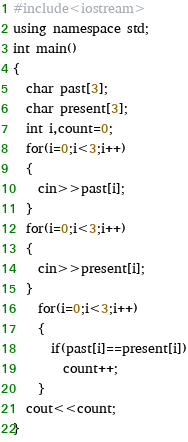Convert code to text. <code><loc_0><loc_0><loc_500><loc_500><_C++_>#include<iostream>
using namespace std;
int main()
{
  char past[3];
  char present[3];
  int i,count=0;
  for(i=0;i<3;i++)
  {
    cin>>past[i];
  }
  for(i=0;i<3;i++)
  {
    cin>>present[i];
  }
    for(i=0;i<3;i++)
    {
      if(past[i]==present[i])
        count++;
    }
  cout<<count;
}</code> 